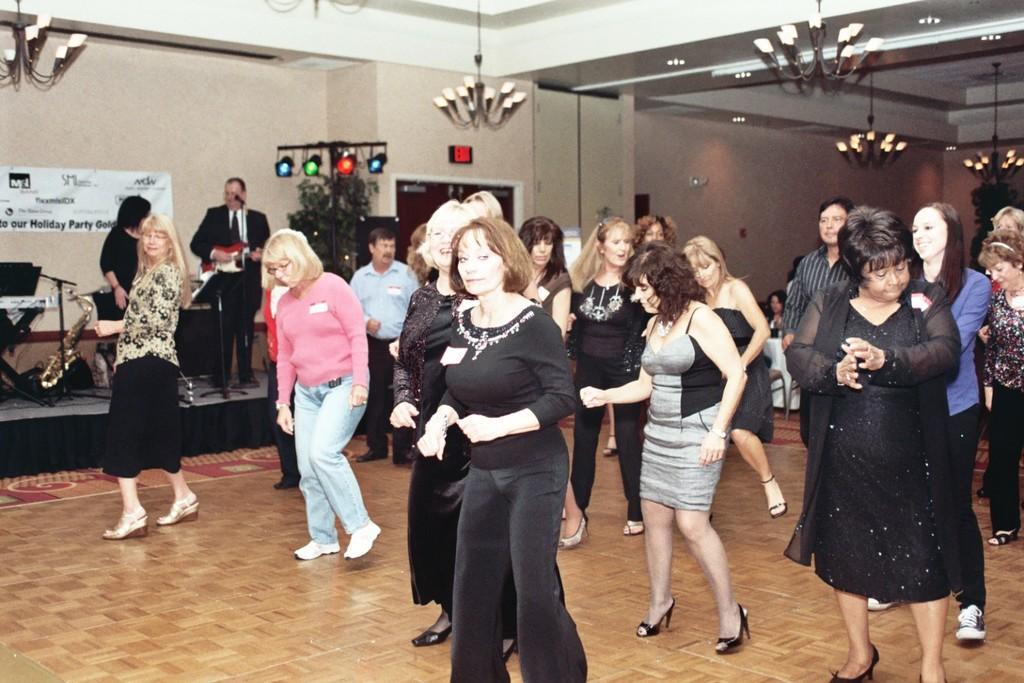How would you summarize this image in a sentence or two? In the picture we can see a few women are dancing on the floor and beside them, we can see two people are playing some musical instruments and beside them, we can see an exit door and to the ceiling we can see some lights and chandeliers. 